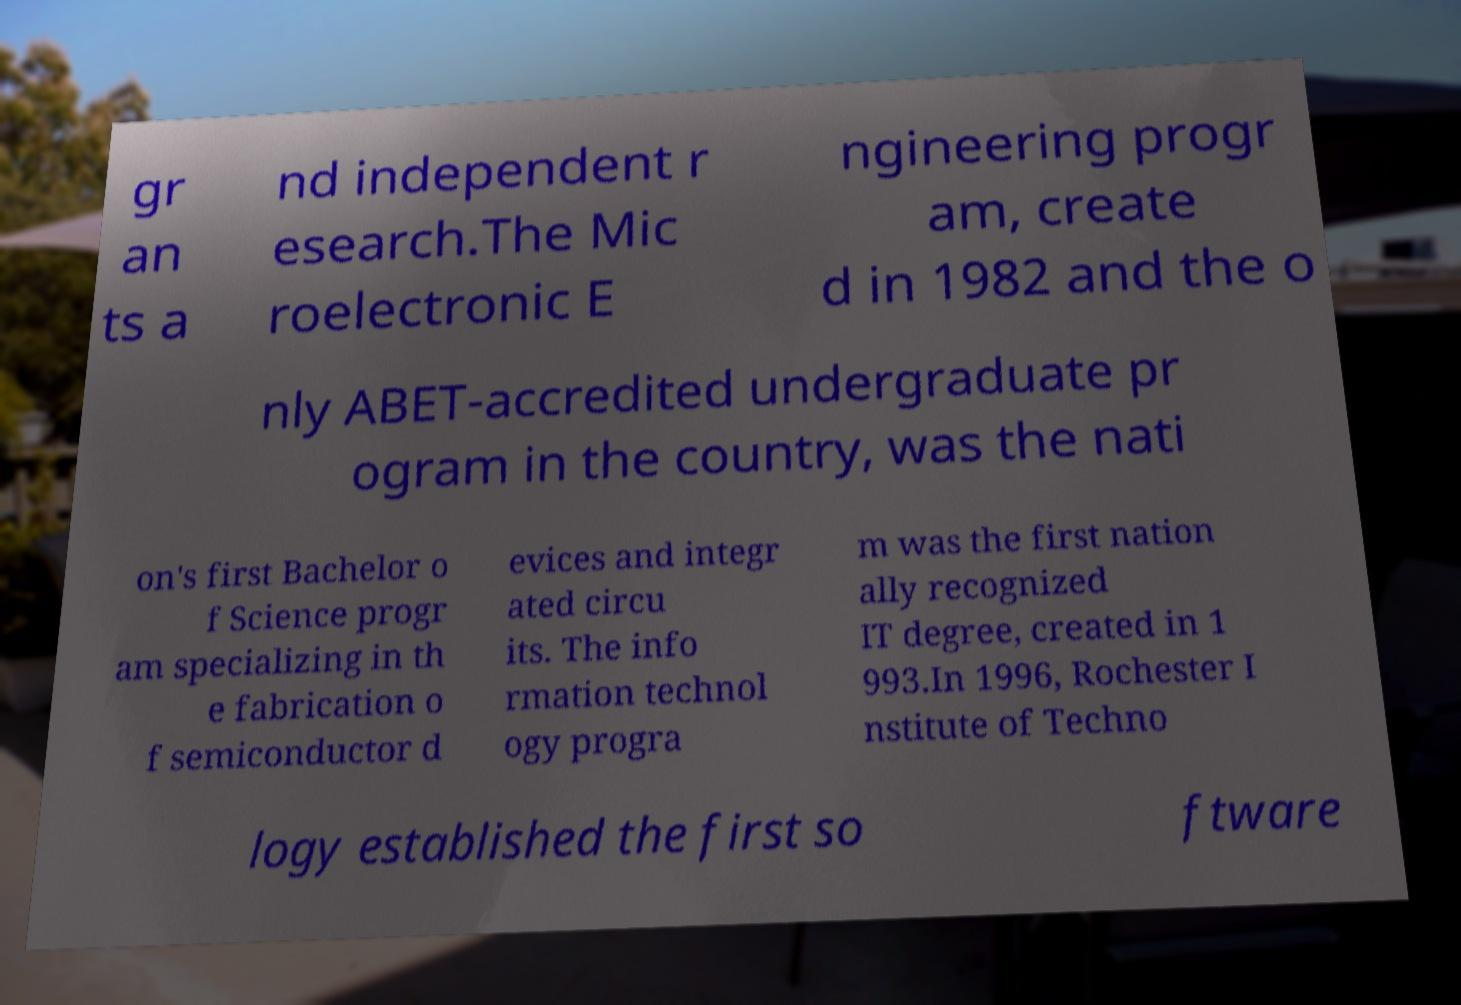What messages or text are displayed in this image? I need them in a readable, typed format. gr an ts a nd independent r esearch.The Mic roelectronic E ngineering progr am, create d in 1982 and the o nly ABET-accredited undergraduate pr ogram in the country, was the nati on's first Bachelor o f Science progr am specializing in th e fabrication o f semiconductor d evices and integr ated circu its. The info rmation technol ogy progra m was the first nation ally recognized IT degree, created in 1 993.In 1996, Rochester I nstitute of Techno logy established the first so ftware 